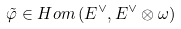<formula> <loc_0><loc_0><loc_500><loc_500>\tilde { \varphi } \in H o m \left ( E ^ { \vee } , E ^ { \vee } \otimes \omega \right )</formula> 